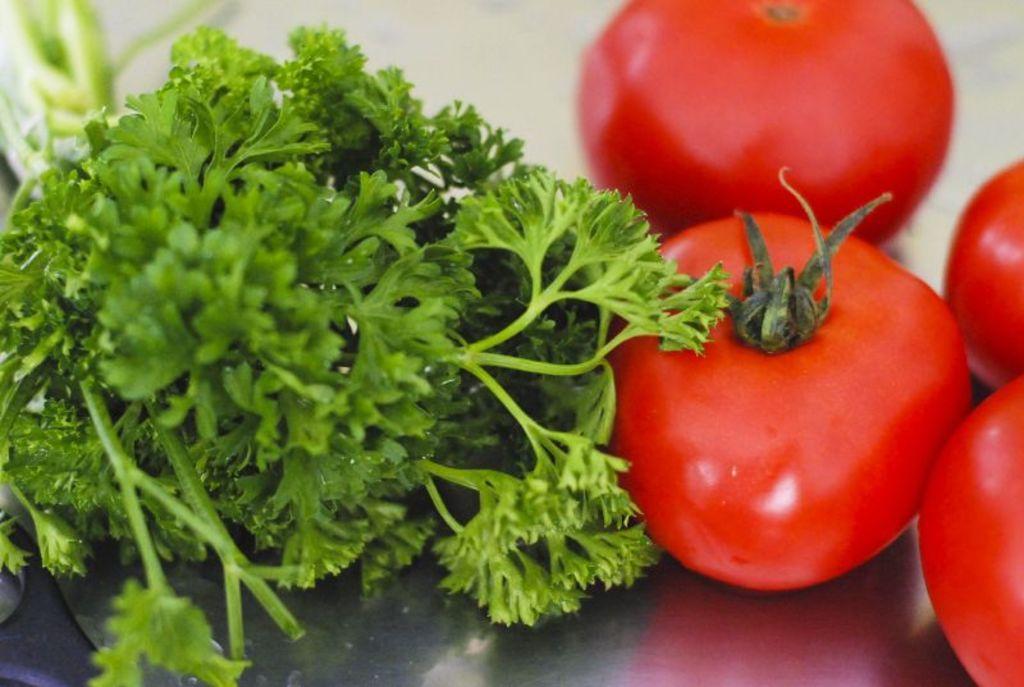How would you summarize this image in a sentence or two? In this image there is a plate, in that place there are tomatoes and coriander. 